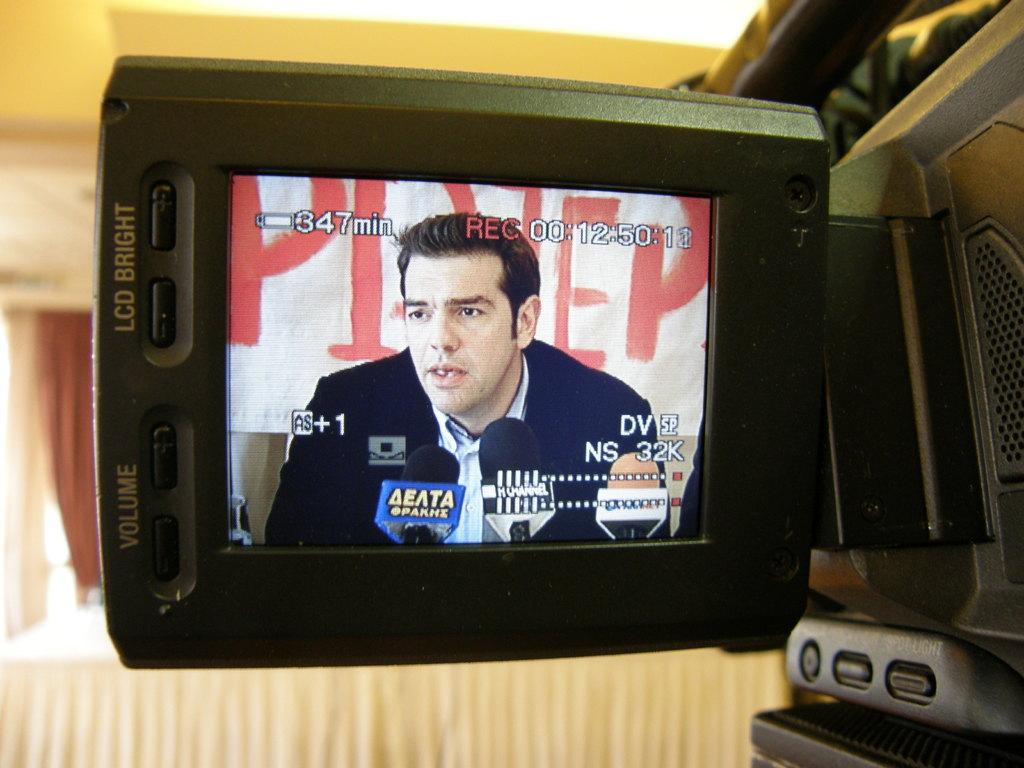What device is the main subject of the picture? There is a video camera in the picture. What can be seen on the video camera's display? A man wearing a coat is visible on the video camera's display. What other equipment is present in the picture? There are microphones in the picture. What type of creature is playing with the balls in the image? There are no balls or creatures present in the image. 